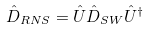<formula> <loc_0><loc_0><loc_500><loc_500>\hat { D } _ { R N S } = \hat { U } \hat { D } _ { S W } \hat { U } ^ { \dag }</formula> 